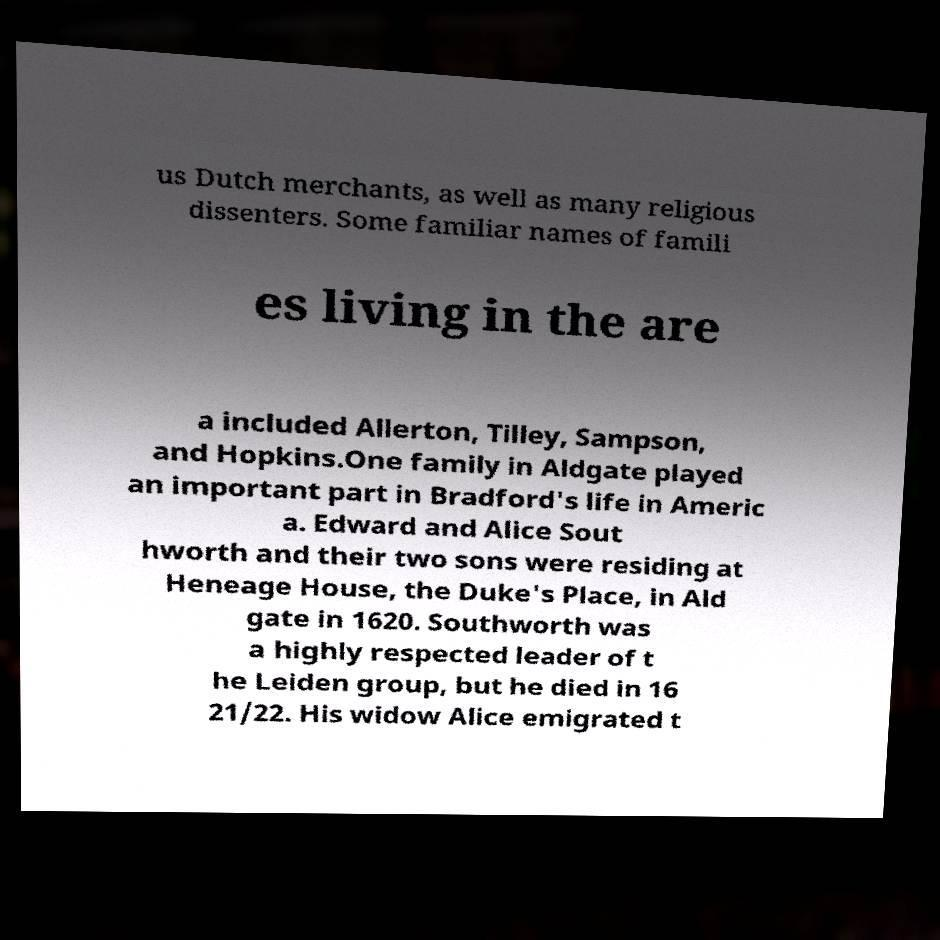What messages or text are displayed in this image? I need them in a readable, typed format. us Dutch merchants, as well as many religious dissenters. Some familiar names of famili es living in the are a included Allerton, Tilley, Sampson, and Hopkins.One family in Aldgate played an important part in Bradford's life in Americ a. Edward and Alice Sout hworth and their two sons were residing at Heneage House, the Duke's Place, in Ald gate in 1620. Southworth was a highly respected leader of t he Leiden group, but he died in 16 21/22. His widow Alice emigrated t 